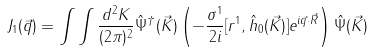<formula> <loc_0><loc_0><loc_500><loc_500>J _ { 1 } ( \vec { q } ) = \int \int \frac { d ^ { 2 } K } { ( 2 \pi ) ^ { 2 } } \hat { \Psi } ^ { \dagger } ( \vec { K } ) \left ( - \frac { \sigma ^ { 1 } } { 2 i } [ r ^ { 1 } , \hat { h } _ { 0 } ( \vec { K } ) ] e ^ { i \vec { q } \cdot \vec { R } } \right ) \hat { \Psi } ( \vec { K } )</formula> 